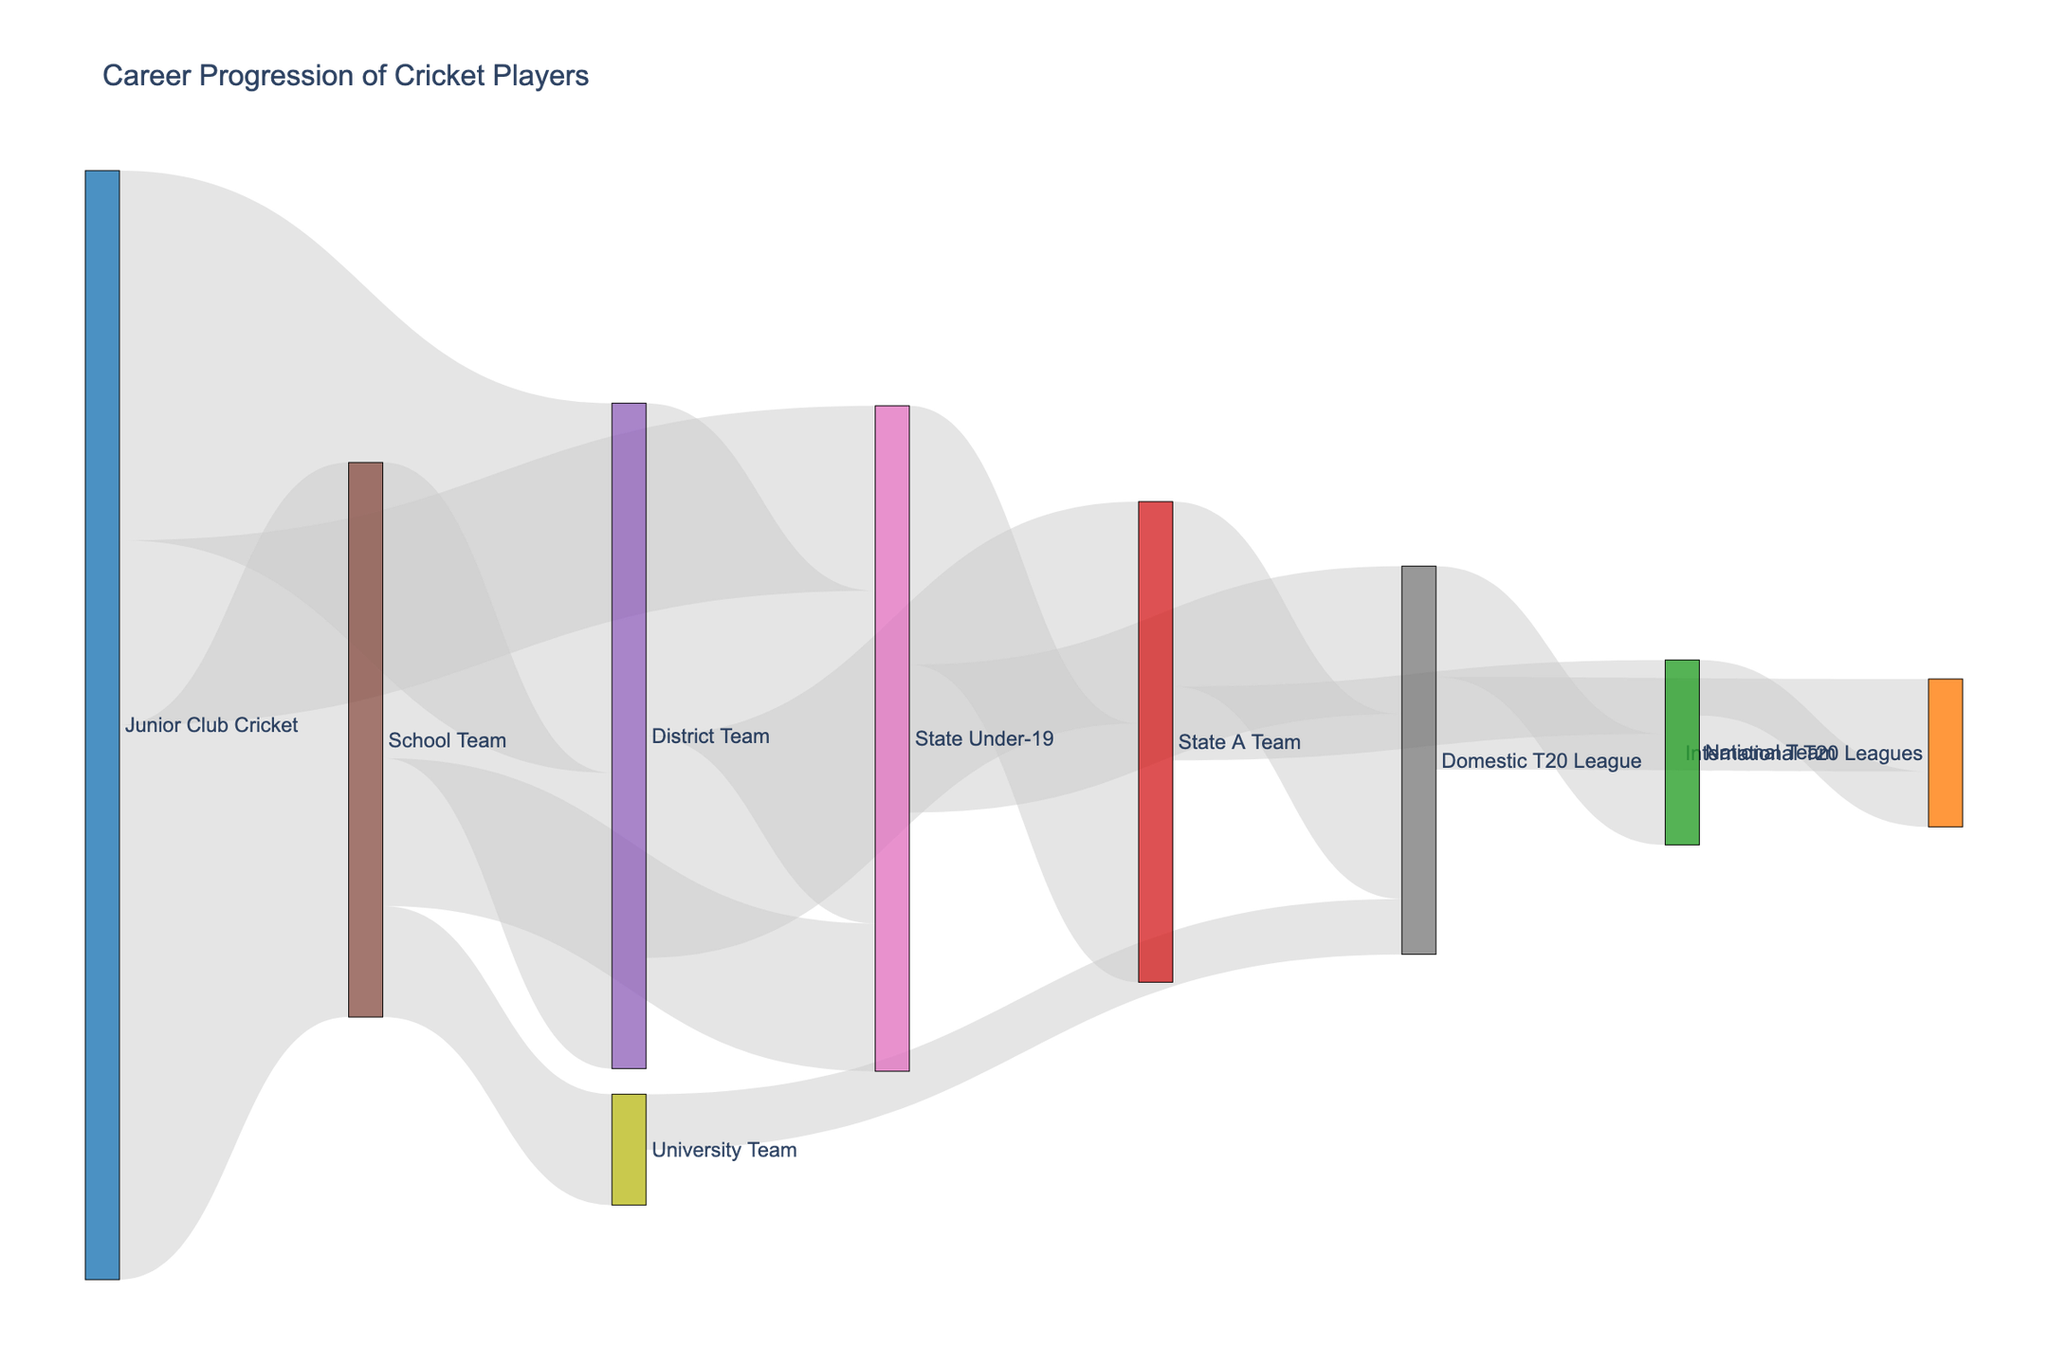what is the total number of players who progressed to the Domestic T20 League from any prior level? Sum the values for transitions to the Domestic T20 League from State Under-19, State A Team, and University Team (40+ 50 + 15).
Answer: 105 Which pathways involve the highest number of players? Look for the largest value in the "value" column, which shows the number of players transitioning from Junior Club Cricket to School Team.
Answer: Junior Club Cricket to School Team How many players progressed from School Team to State Under-19? Look for the specific flow from School Team to State Under-19 in the "value" column.
Answer: 40 Between the National Team and International T20 Leagues, which received more players from the Domestic T20 League? Compare the values flowing from Domestic T20 League to National Team and International T20 Leagues (30 vs. 25).
Answer: National Team What is the combined number of players who progressed from State Under-19 to either State A Team or Domestic T20 League? Sum the values for transitions from State Under-19 to State A Team and Domestic T20 League (70 + 40).
Answer: 110 How many players in total moved from Junior Club Cricket to any other category? Sum all the values stemming from Junior Club Cricket (150 + 100 + 50).
Answer: 300 Is there a higher number of players progressing from the District Team to State A Team or progressing to the National Team from State A Team? Compare the values flowing from District Team to State A Team and State A Team to National Team (60 vs. 20).
Answer: District Team to State A Team From which initial category do the highest number of players eventually reach the National Team? Trace the pathways with the highest total flow leading to the National Team (State A Team -> National Team (20) and Domestic T20 League -> National Team (30), summing the inflows from preceding categories to the State A Team and Domestic T20 League).
Answer: Domestic T20 League Which level has the least number of players progressing to it? Identify the target with the smallest cumulative value flowing into it. Cross-check values for all target categories and sum if there are multiple flows to a target.
Answer: International T20 Leagues How many more players progressed from Junior Club Cricket to District Team compared to those who progressed from Junior Club Cricket to State Under-19? Subtract the number of players transitioning to State Under-19 from those transitioning to District Team (100 - 50).
Answer: 50 